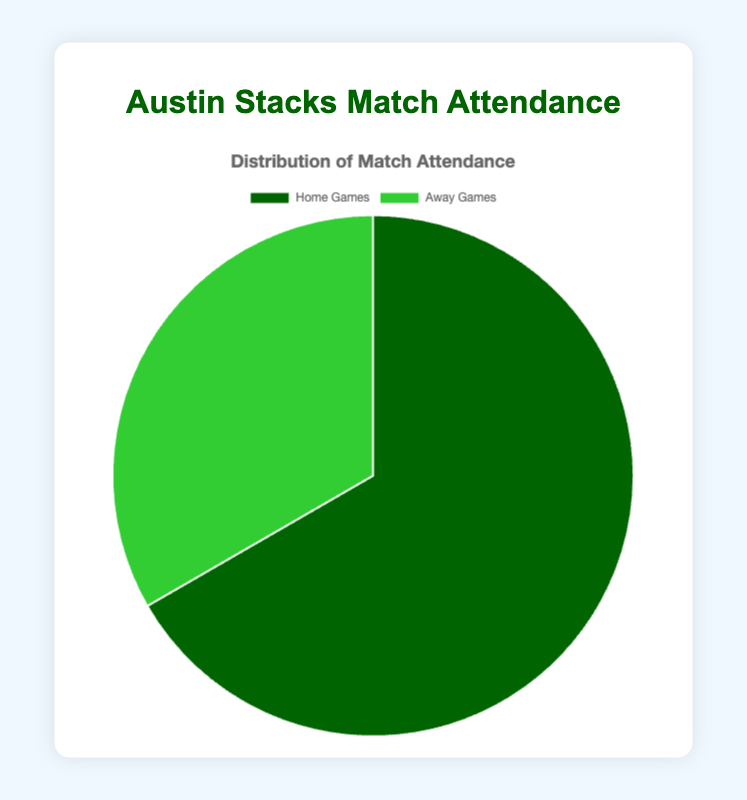What's the total match attendance? The total match attendance is found by summing up the attendance for Home Games and Away Games. Home Games have 15,000 attendees and Away Games have 7,500 attendees. Therefore, the total attendance is 15,000 + 7,500 = 22,500.
Answer: 22,500 Which type of match has the higher attendance? To determine the match type with higher attendance, compare the values for Home Games and Away Games. Home Games have 15,000 attendees, while Away Games have 7,500 attendees. Hence, Home Games have a higher attendance.
Answer: Home Games What fraction of the total attendance is represented by Home Games? The fraction of Home Games attendance over the total attendance is found by dividing the Home Games attendance by the total attendance. Total attendance = 22,500 and Home Games attendance = 15,000. So, the fraction is 15,000 / 22,500 = 2/3.
Answer: 2/3 How much higher is the Home Games turnout compared to Away Games? To find out how much higher Home Games turnout is compared to Away Games turnout, subtract Away Games attendance from Home Games attendance. Home Games attendance = 15,000 and Away Games attendance = 7,500. Therefore, the difference is 15,000 - 7,500 = 7,500.
Answer: 7,500 What's the percentage of total attendance due to Away Games? To find the percentage of total attendance contributed by Away Games, divide the Away Games attendance by the total attendance and multiply by 100. Away Games attendance = 7,500 and total attendance = 22,500. So, the percentage is (7,500 / 22,500) * 100 = 33.33%.
Answer: 33.33% If the total attendance next season is expected to be 50% higher, what would be the new attendance for Home Games, assuming the distribution remains the same? First, calculate the new total attendance which would be 150% of the current total. Current total = 22,500, so new total = 22,500 * 1.5 = 33,750. Given the Home Games current fraction of total is 2/3, the new Home Games attendance would be 2/3 of 33,750. So, new Home Games attendance = 33,750 * 2/3 = 22,500.
Answer: 22,500 What color represents Away Games in the pie chart? From the visual attributes in the figure, Away Games are represented by the lighter shade of green.
Answer: Lighter green 